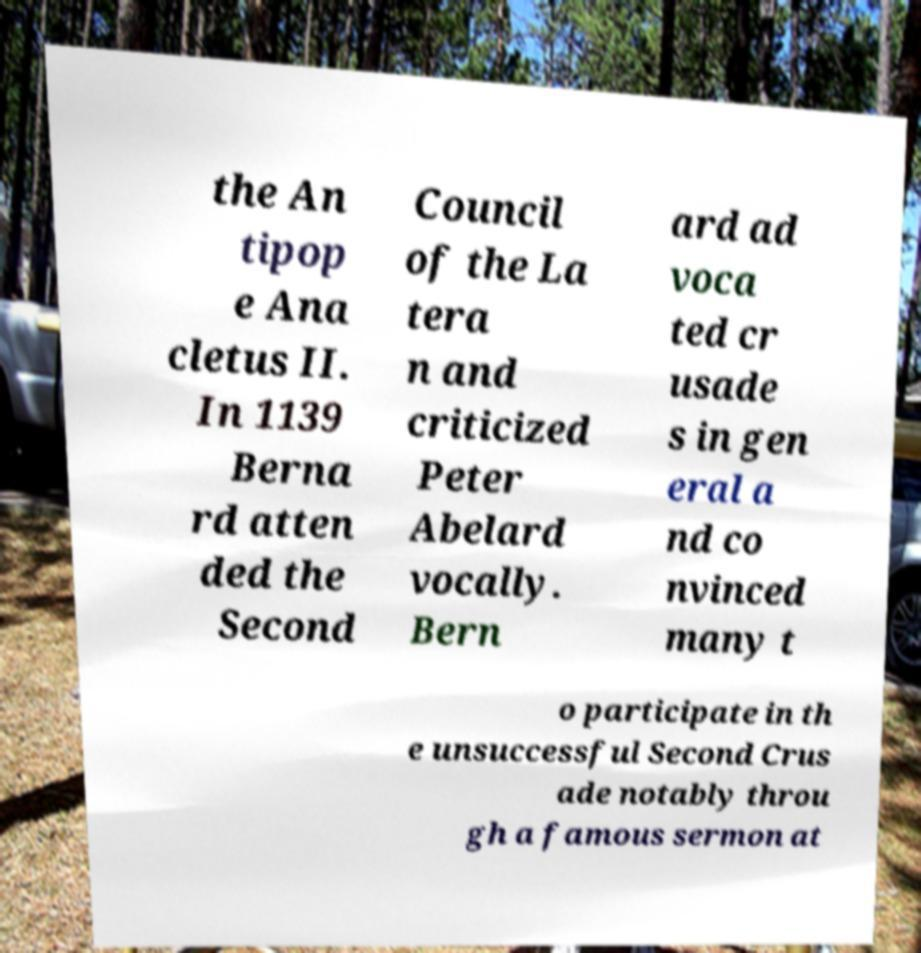There's text embedded in this image that I need extracted. Can you transcribe it verbatim? the An tipop e Ana cletus II. In 1139 Berna rd atten ded the Second Council of the La tera n and criticized Peter Abelard vocally. Bern ard ad voca ted cr usade s in gen eral a nd co nvinced many t o participate in th e unsuccessful Second Crus ade notably throu gh a famous sermon at 